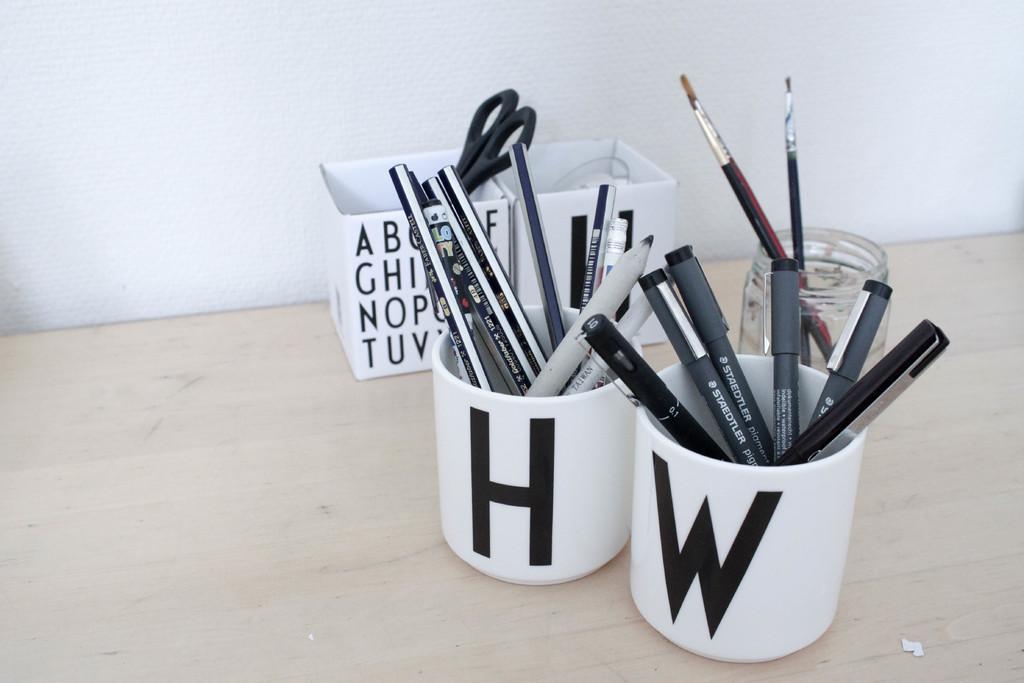In one or two sentences, can you explain what this image depicts? On this wooden surface we can see a jar, cups, boxes, pens, pencils, scissors and paint brushes. Background there is a white wall. 